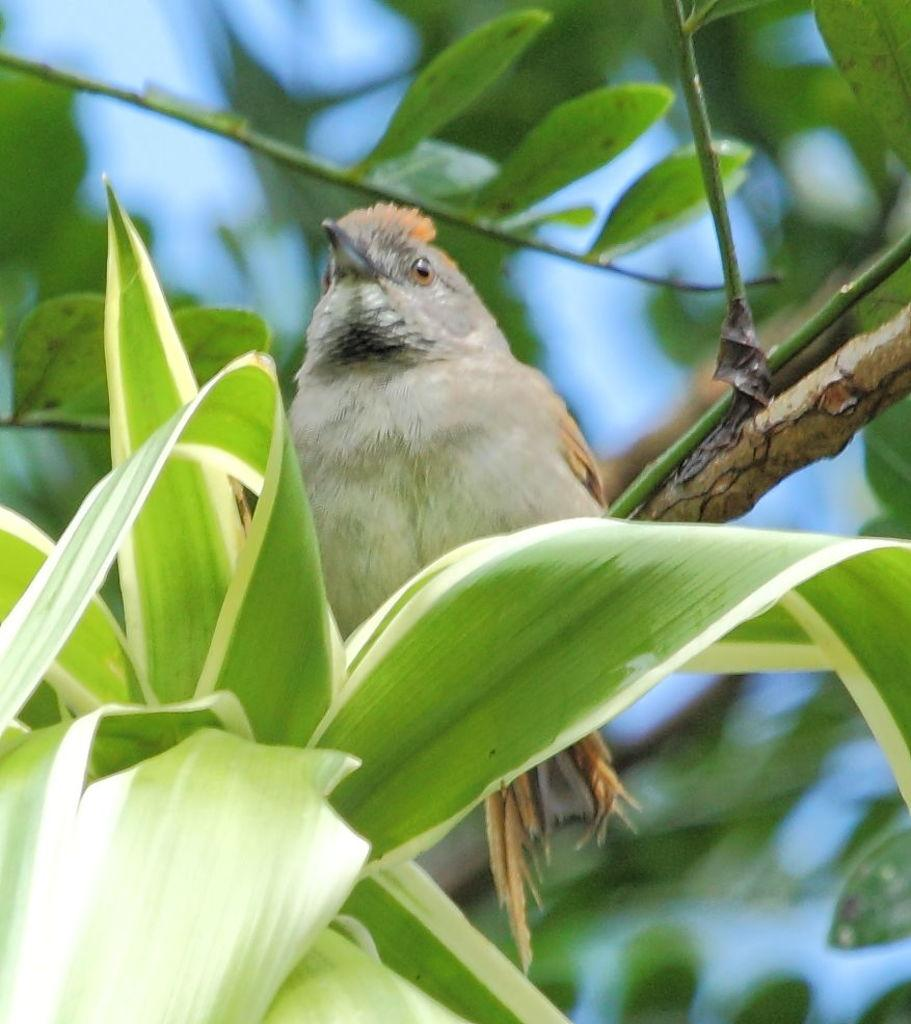What type of animal can be seen in the image? There is a bird in the image. What is covering the bird in the image? There are leaves in front of the bird. Can you describe the background of the image? The background of the image is blurred. What type of committee is meeting in the image? There is no committee present in the image; it features a bird with leaves in front of it and a blurred background. How many berries can be seen on the bird in the image? There are no berries present on the bird in the image. 